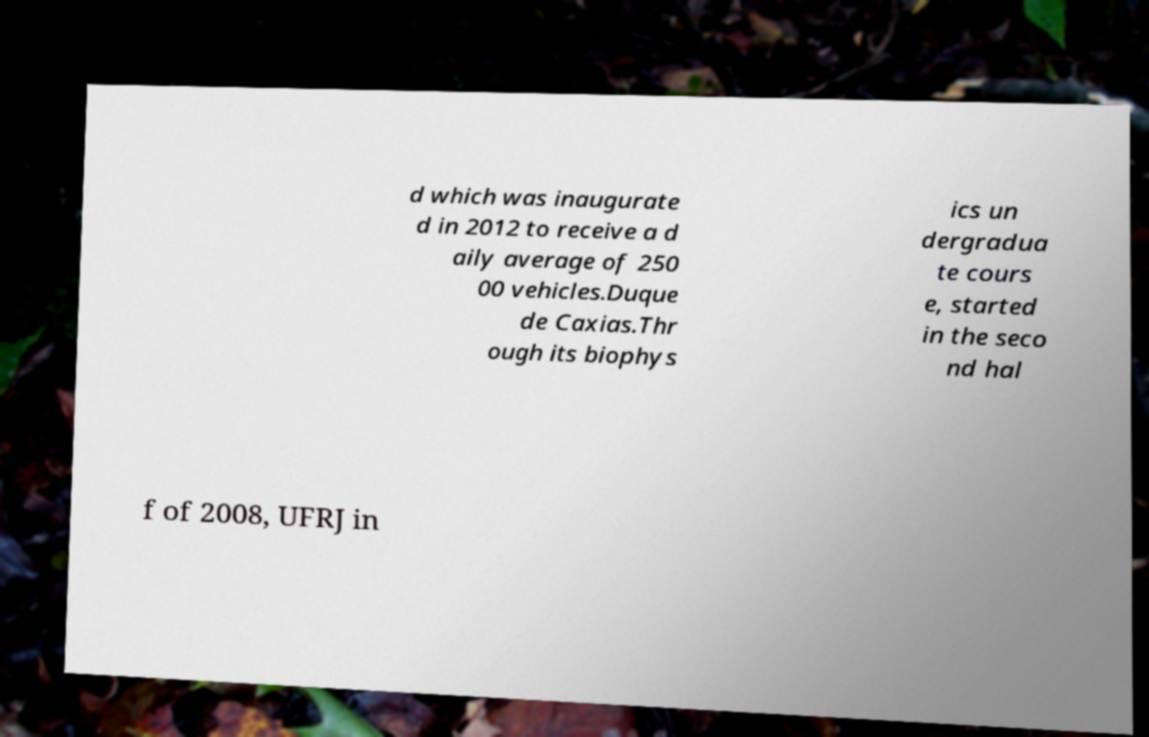Could you assist in decoding the text presented in this image and type it out clearly? d which was inaugurate d in 2012 to receive a d aily average of 250 00 vehicles.Duque de Caxias.Thr ough its biophys ics un dergradua te cours e, started in the seco nd hal f of 2008, UFRJ in 